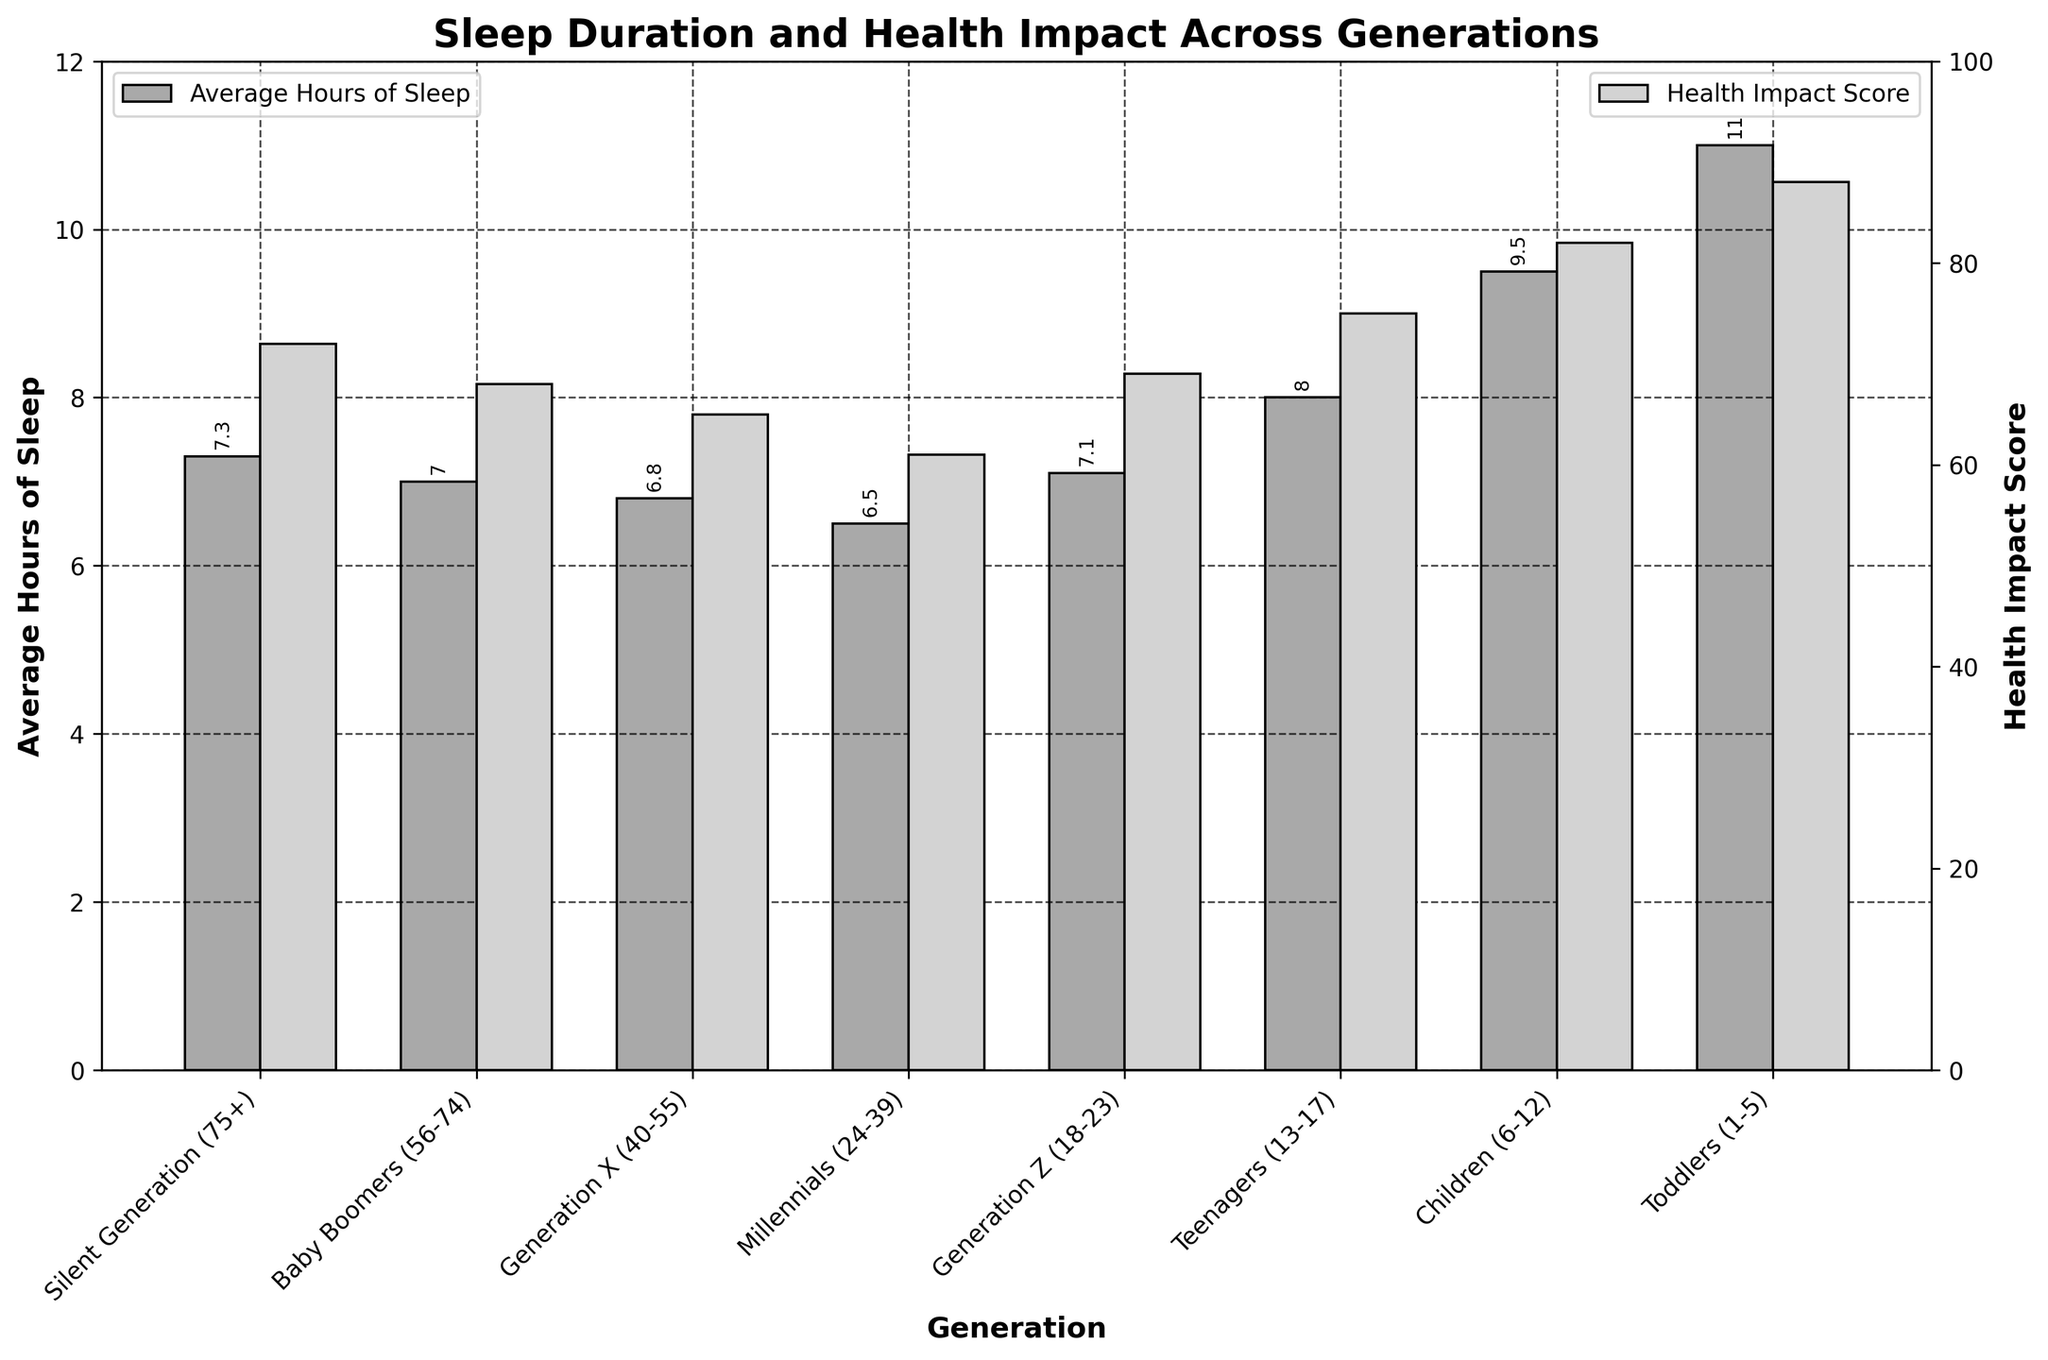Which generation gets the most average hours of sleep per night? The bar representing Average Hours of Sleep shows that Toddlers (1-5) have the tallest bar, indicating they get the most sleep per night.
Answer: Toddlers (1-5) What is the difference in the Health Impact Score between Children (6-12) and Millennials (24-39)? Compare the heights of the bars representing the Health Impact Scores for Children (6-12) and Millennials (24-39). Children have a score of 82, whereas Millennials have a score of 61. The difference is 82 - 61.
Answer: 21 How much more sleep do Teenagers (13-17) get compared to Generation X (40-55)? The Average Hours of Sleep for Teenagers (13-17) is represented as 8.0 hours, and for Generation X (40-55), it is 6.8 hours. The difference is 8.0 - 6.8.
Answer: 1.2 hours Which generation has the lowest Health Impact Score and what is it? The bar for Health Impact Score is the shortest for Millennials (24-39), indicating they have the lowest score of 61.
Answer: Millennials (24-39), 61 How do the average hours of sleep for the Silent Generation (75+) compare to those for Baby Boomers (56-74)? The bars for Average Hours of Sleep show the Silent Generation (75+) getting 7.3 hours, while Baby Boomers (56-74) get 7.0 hours. The Silent Generation gets 0.3 hours more sleep.
Answer: 0.3 hours more What is the sum of the Health Impact Scores for Generation Z (18-23) and Teenagers (13-17)? The Health Impact Score for Generation Z (18-23) is 69 and for Teenagers (13-17) is 75. The sum is calculated as 69 + 75.
Answer: 144 Which group has a Health Impact Score of 88 and what is their average sleep duration? The bar for Health Impact Score of 88 corresponds to Toddlers (1-5), who have an average sleep duration of 11.0 hours.
Answer: Toddlers (1-5), 11.0 hours Is the average sleep time for Children (6-12) higher than for Generation Z (18-23)? The bar for Average Hours of Sleep shows Children (6-12) get 9.5 hours, while Generation Z (18-23) gets 7.1 hours. Children sleep more on average.
Answer: Yes What is the total average sleep duration for Generations X (40-55) and Baby Boomers (56-74)? The Average Hours of Sleep for Generation X (40-55) is 6.8 hours, and for Baby Boomers (56-74) is 7.0 hours. The total is 6.8 + 7.0.
Answer: 13.8 hours Compare the visual height of Sleep Duration and Health Impact Score bars for Millennials (24-39). Which one is relatively higher? Visually compare the height of the two bars. The Health Impact Score bar for Millennials (24-39) is slightly shorter than the Sleep Duration bar.
Answer: Sleep Duration bar is higher 